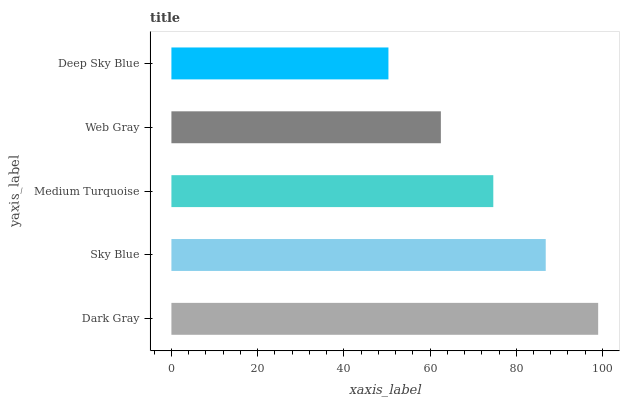Is Deep Sky Blue the minimum?
Answer yes or no. Yes. Is Dark Gray the maximum?
Answer yes or no. Yes. Is Sky Blue the minimum?
Answer yes or no. No. Is Sky Blue the maximum?
Answer yes or no. No. Is Dark Gray greater than Sky Blue?
Answer yes or no. Yes. Is Sky Blue less than Dark Gray?
Answer yes or no. Yes. Is Sky Blue greater than Dark Gray?
Answer yes or no. No. Is Dark Gray less than Sky Blue?
Answer yes or no. No. Is Medium Turquoise the high median?
Answer yes or no. Yes. Is Medium Turquoise the low median?
Answer yes or no. Yes. Is Web Gray the high median?
Answer yes or no. No. Is Dark Gray the low median?
Answer yes or no. No. 